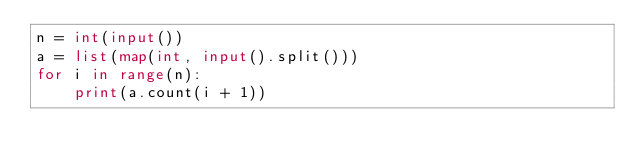Convert code to text. <code><loc_0><loc_0><loc_500><loc_500><_Python_>n = int(input())
a = list(map(int, input().split()))
for i in range(n):
    print(a.count(i + 1))
</code> 